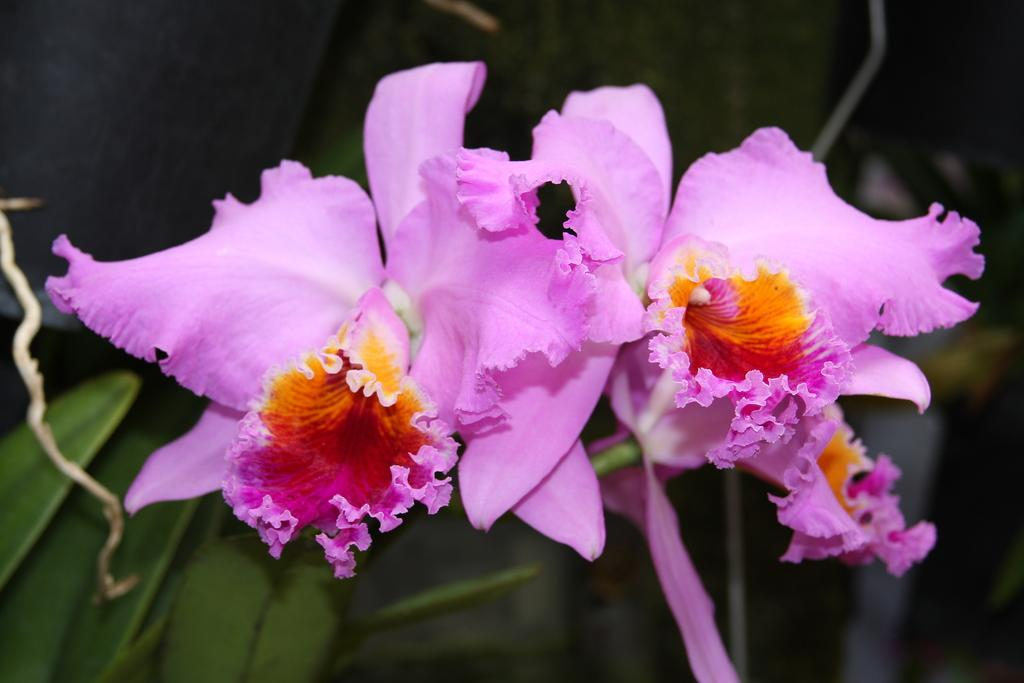What type of plants can be seen in the image? There are flowers in the image. What color are the flowers? The flowers are pink in color. What else can be seen at the bottom of the image? There are leaves visible at the bottom of the image. How does the flower show respect to the other flowers in the image? There is no indication in the image that the flowers are showing respect to each other, as flowers do not have the ability to express emotions or intentions. 